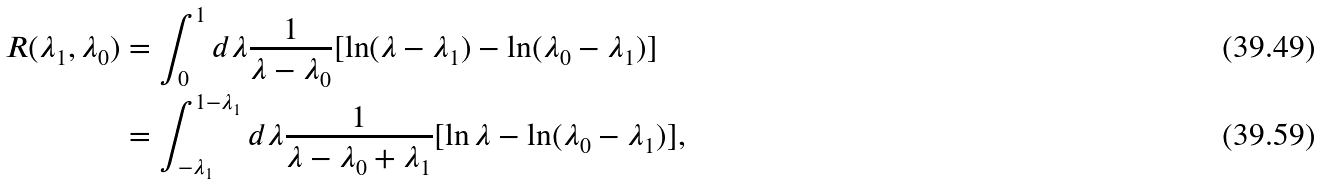Convert formula to latex. <formula><loc_0><loc_0><loc_500><loc_500>R ( \lambda _ { 1 } , \lambda _ { 0 } ) & = \int _ { 0 } ^ { 1 } d \lambda \frac { 1 } { \lambda - \lambda _ { 0 } } [ \ln ( \lambda - \lambda _ { 1 } ) - \ln ( \lambda _ { 0 } - \lambda _ { 1 } ) ] \\ & = \int _ { - \lambda _ { 1 } } ^ { 1 - \lambda _ { 1 } } d \lambda \frac { 1 } { \lambda - \lambda _ { 0 } + \lambda _ { 1 } } [ \ln \lambda - \ln ( \lambda _ { 0 } - \lambda _ { 1 } ) ] ,</formula> 